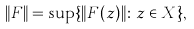<formula> <loc_0><loc_0><loc_500><loc_500>\| F \| = \sup \{ \| F ( z ) \| \colon z \in X \} ,</formula> 